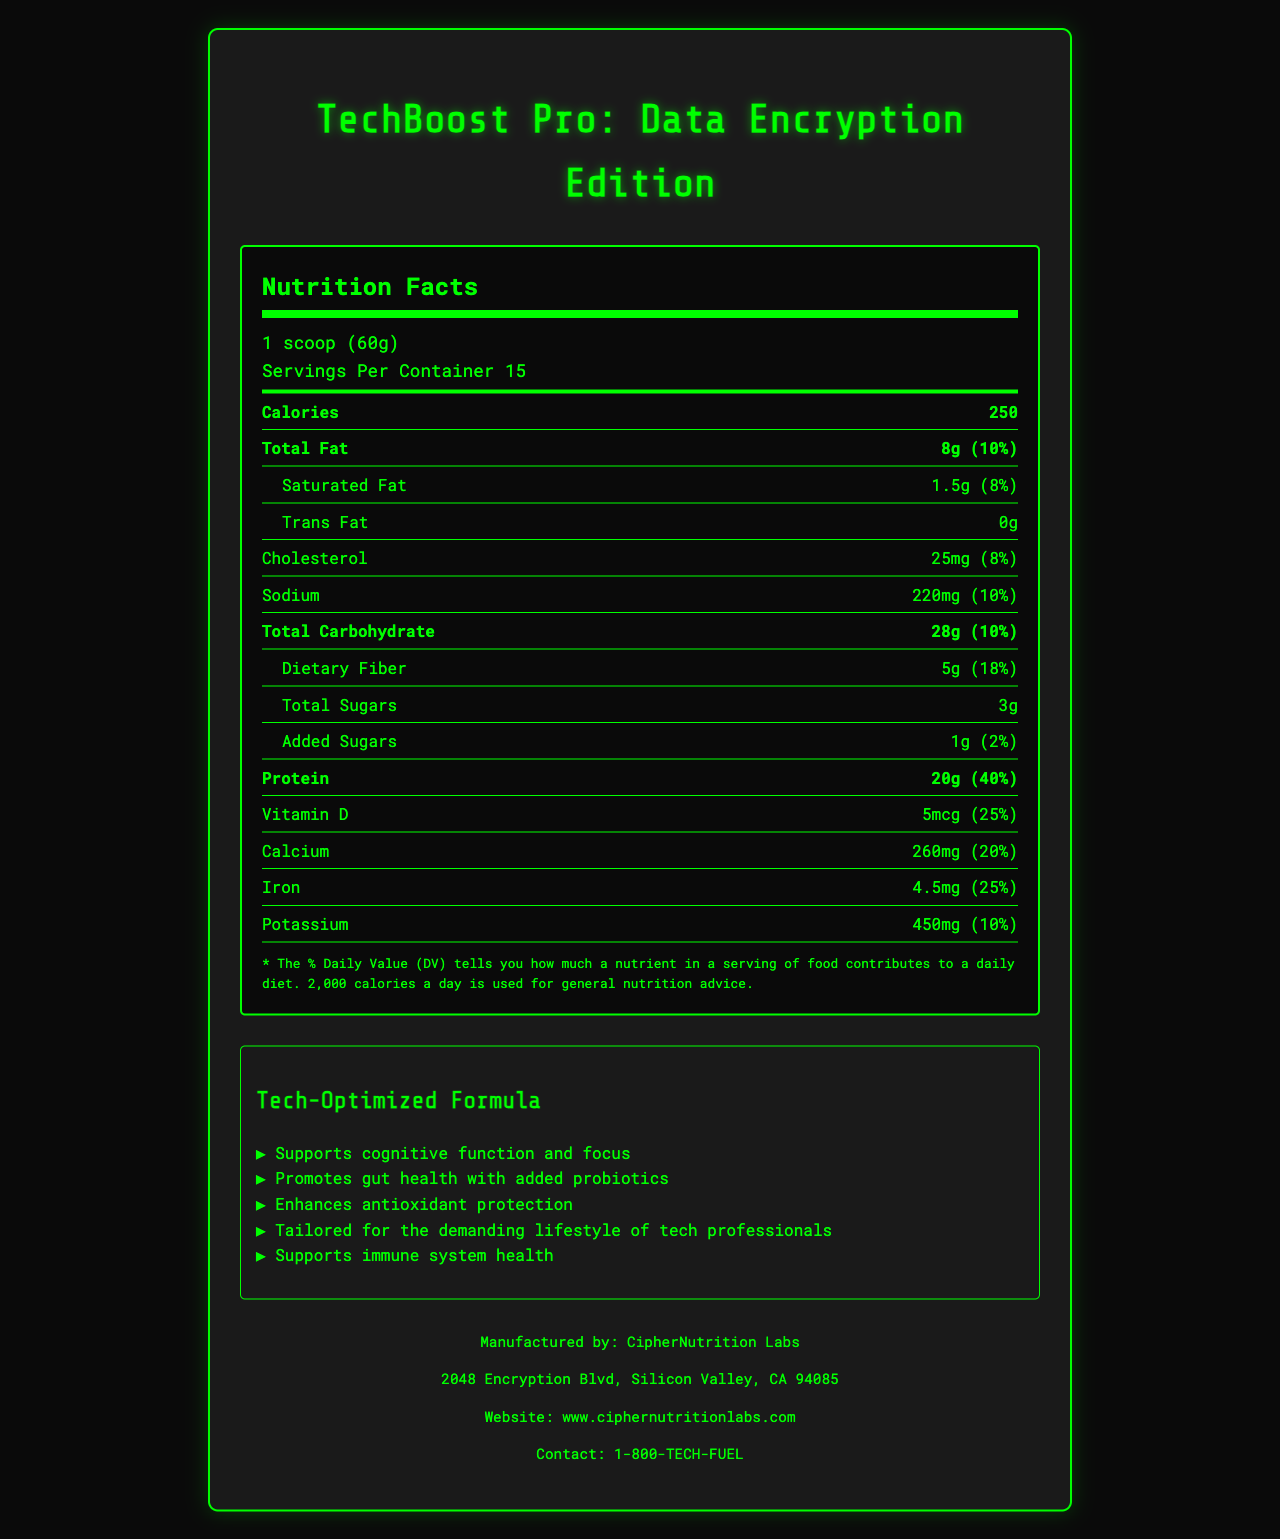what is the serving size? The document states that the serving size is 1 scoop (60g).
Answer: 1 scoop (60g) how many servings are there per container? The label mentions that there are 15 servings per container.
Answer: 15 how many calories are in one serving? The Nutrition Facts indicate that one serving contains 250 calories.
Answer: 250 how much protein does one serving provide? According to the label, one serving contains 20g of protein.
Answer: 20g what are the ingredients in the antioxidant blend? The document lists the ingredients in the antioxidant blend as Green tea extract, Resveratrol, Coenzyme Q10, and Astaxanthin.
Answer: Green tea extract, Resveratrol, Coenzyme Q10, Astaxanthin how much dietary fiber is in one serving? The amount of dietary fiber per serving is 5g.
Answer: 5g What is the % Daily Value of Vitamin B12? The document indicates that Vitamin B12 has a 125% Daily Value per serving.
Answer: 125% Which of the following nutrients has the highest % Daily Value?
A. Vitamin D 
B. Calcium 
C. Vitamin A 
D. Vitamin B12 Vitamin B12 has a % Daily Value of 125%, which is the highest among the provided options.
Answer: D. Vitamin B12 What should you do with the product after opening it? 
A. Keep it in a cool place 
B. Refrigerate it 
C. Consume it immediately 
D. Freeze it The storage instructions specify that you should refrigerate the product after opening it and consume it within 30 days.
Answer: B. Refrigerate it Is the product suitable for individuals with a tree nut allergy? The allergen information states that the product is produced in a facility that also processes tree nuts.
Answer: No Summarize the document. The detailed description encapsulates the main sections and key information provided in the document.
Answer: The document is a Nutrition Facts Label for "TechBoost Pro: Data Encryption Edition," a nutrient-dense meal replacement shake tailored for tech professionals with added antioxidants and probiotics. It provides information on serving size, servings per container, calorie content, and the amounts and daily values of various nutrients, including fats, carbohydrates, protein, vitamins, and minerals. The label also highlights the ingredients in the antioxidant and probiotic blends, lists all ingredients, states allergen information, provides storage instructions, and includes claims about the product's benefits for cognitive function, gut health, antioxidant protection, and immune support. The manufacturer, CipherNutrition Labs, and their contact information are also mentioned. How many grams of saturated fat are there per serving? The document mentions that there are 1.5g of saturated fat per serving.
Answer: 1.5g Which ingredient is not present in the product? 
A. Whey protein isolate 
B. Stevia leaf extract 
C. Soy protein 
D. Chia seeds The document lists whey protein isolate, stevia leaf extract, and chia seeds among the ingredients, but soy protein is not mentioned.
Answer: C. Soy protein What is the purpose of the probiotic blend? One of the claim highlights states that the product promotes gut health due to its added probiotics.
Answer: Promotes gut health What is the daily value percentage of calcium? The document lists the daily value percentage of calcium as 20%.
Answer: 20% What is the contact phone number for the manufacturer? The manufacturer's contact phone number provided in the document is 1-800-TECH-FUEL.
Answer: 1-800-TECH-FUEL What is the role of the antioxidant blend? The claim highlights mention that the product enhances antioxidant protection.
Answer: Enhances antioxidant protection Where is CipherNutrition Labs located? The manufacturer's location is provided as 2048 Encryption Blvd, Silicon Valley, CA 94085.
Answer: 2048 Encryption Blvd, Silicon Valley, CA 94085 What is the role of magnesium in the product? The document lists magnesium as a nutrient but does not specify its role or purpose within the product.
Answer: Cannot be determined 